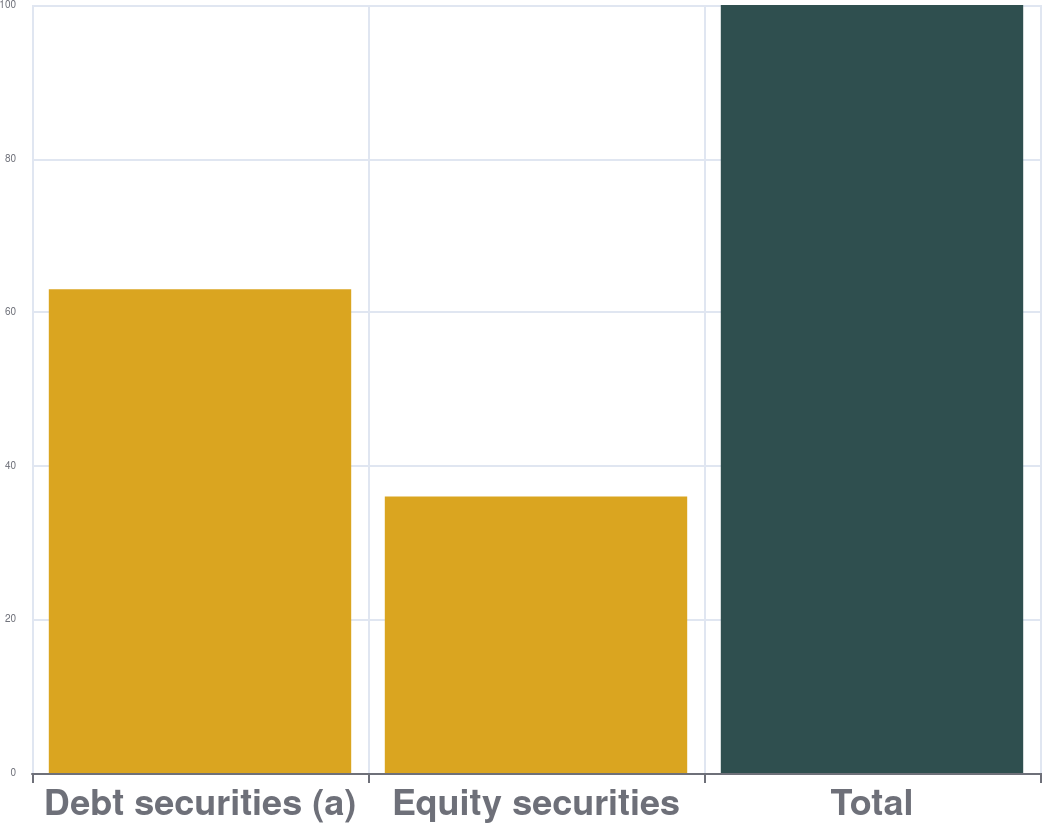Convert chart. <chart><loc_0><loc_0><loc_500><loc_500><bar_chart><fcel>Debt securities (a)<fcel>Equity securities<fcel>Total<nl><fcel>63<fcel>36<fcel>100<nl></chart> 